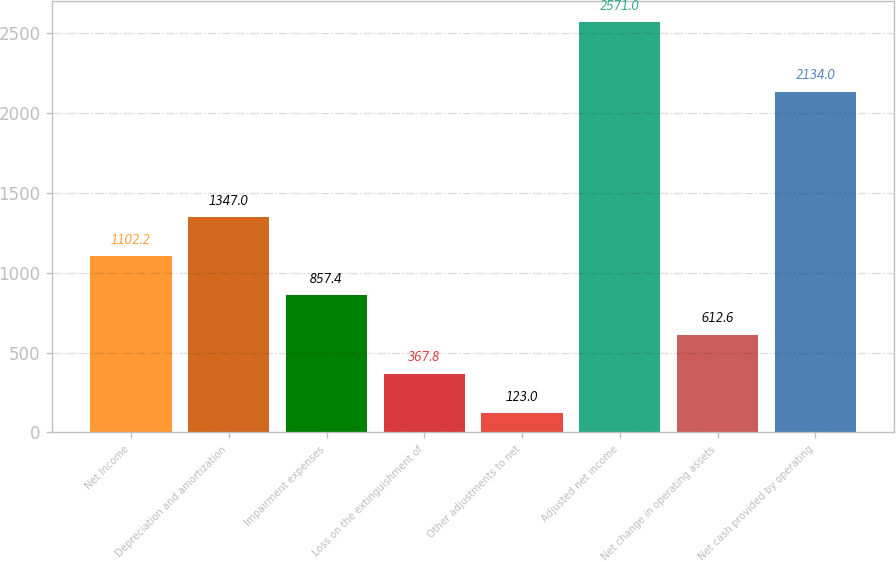Convert chart. <chart><loc_0><loc_0><loc_500><loc_500><bar_chart><fcel>Net Income<fcel>Depreciation and amortization<fcel>Impairment expenses<fcel>Loss on the extinguishment of<fcel>Other adjustments to net<fcel>Adjusted net income<fcel>Net change in operating assets<fcel>Net cash provided by operating<nl><fcel>1102.2<fcel>1347<fcel>857.4<fcel>367.8<fcel>123<fcel>2571<fcel>612.6<fcel>2134<nl></chart> 